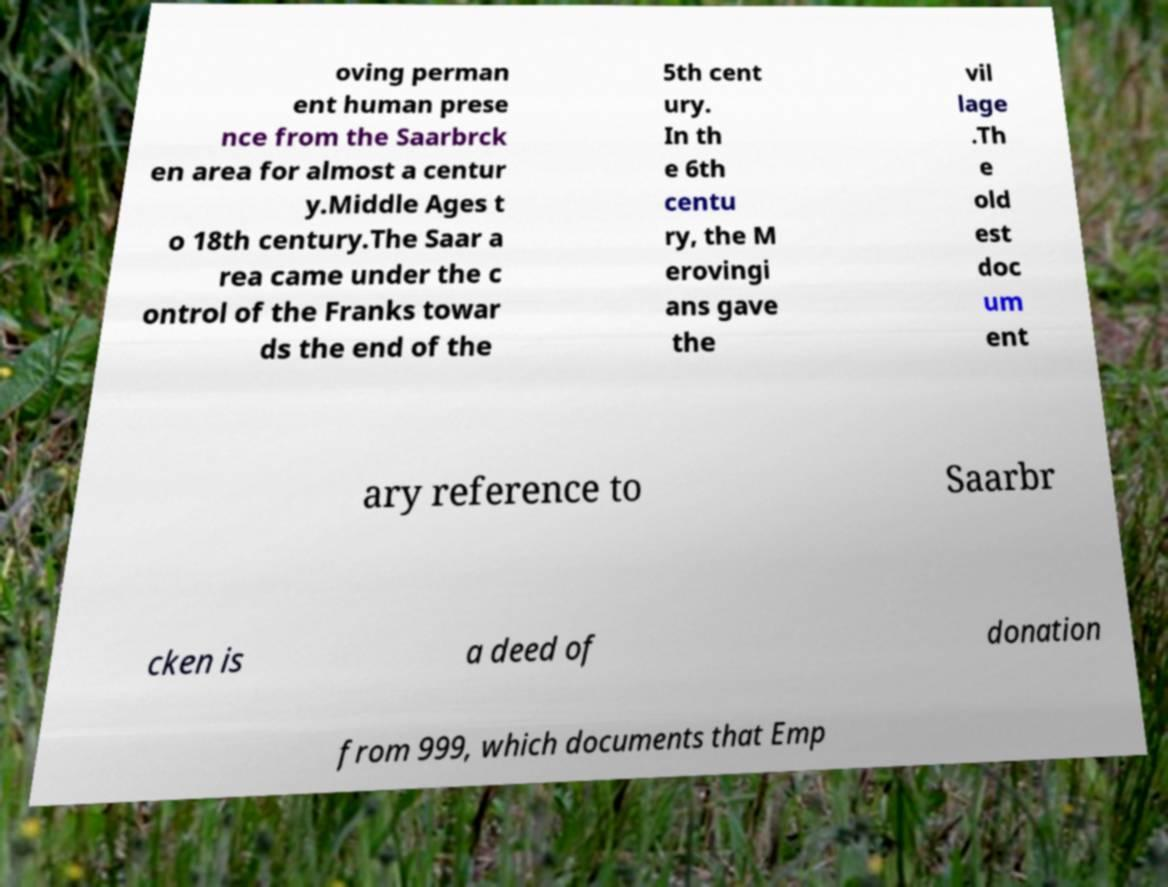Could you assist in decoding the text presented in this image and type it out clearly? oving perman ent human prese nce from the Saarbrck en area for almost a centur y.Middle Ages t o 18th century.The Saar a rea came under the c ontrol of the Franks towar ds the end of the 5th cent ury. In th e 6th centu ry, the M erovingi ans gave the vil lage .Th e old est doc um ent ary reference to Saarbr cken is a deed of donation from 999, which documents that Emp 